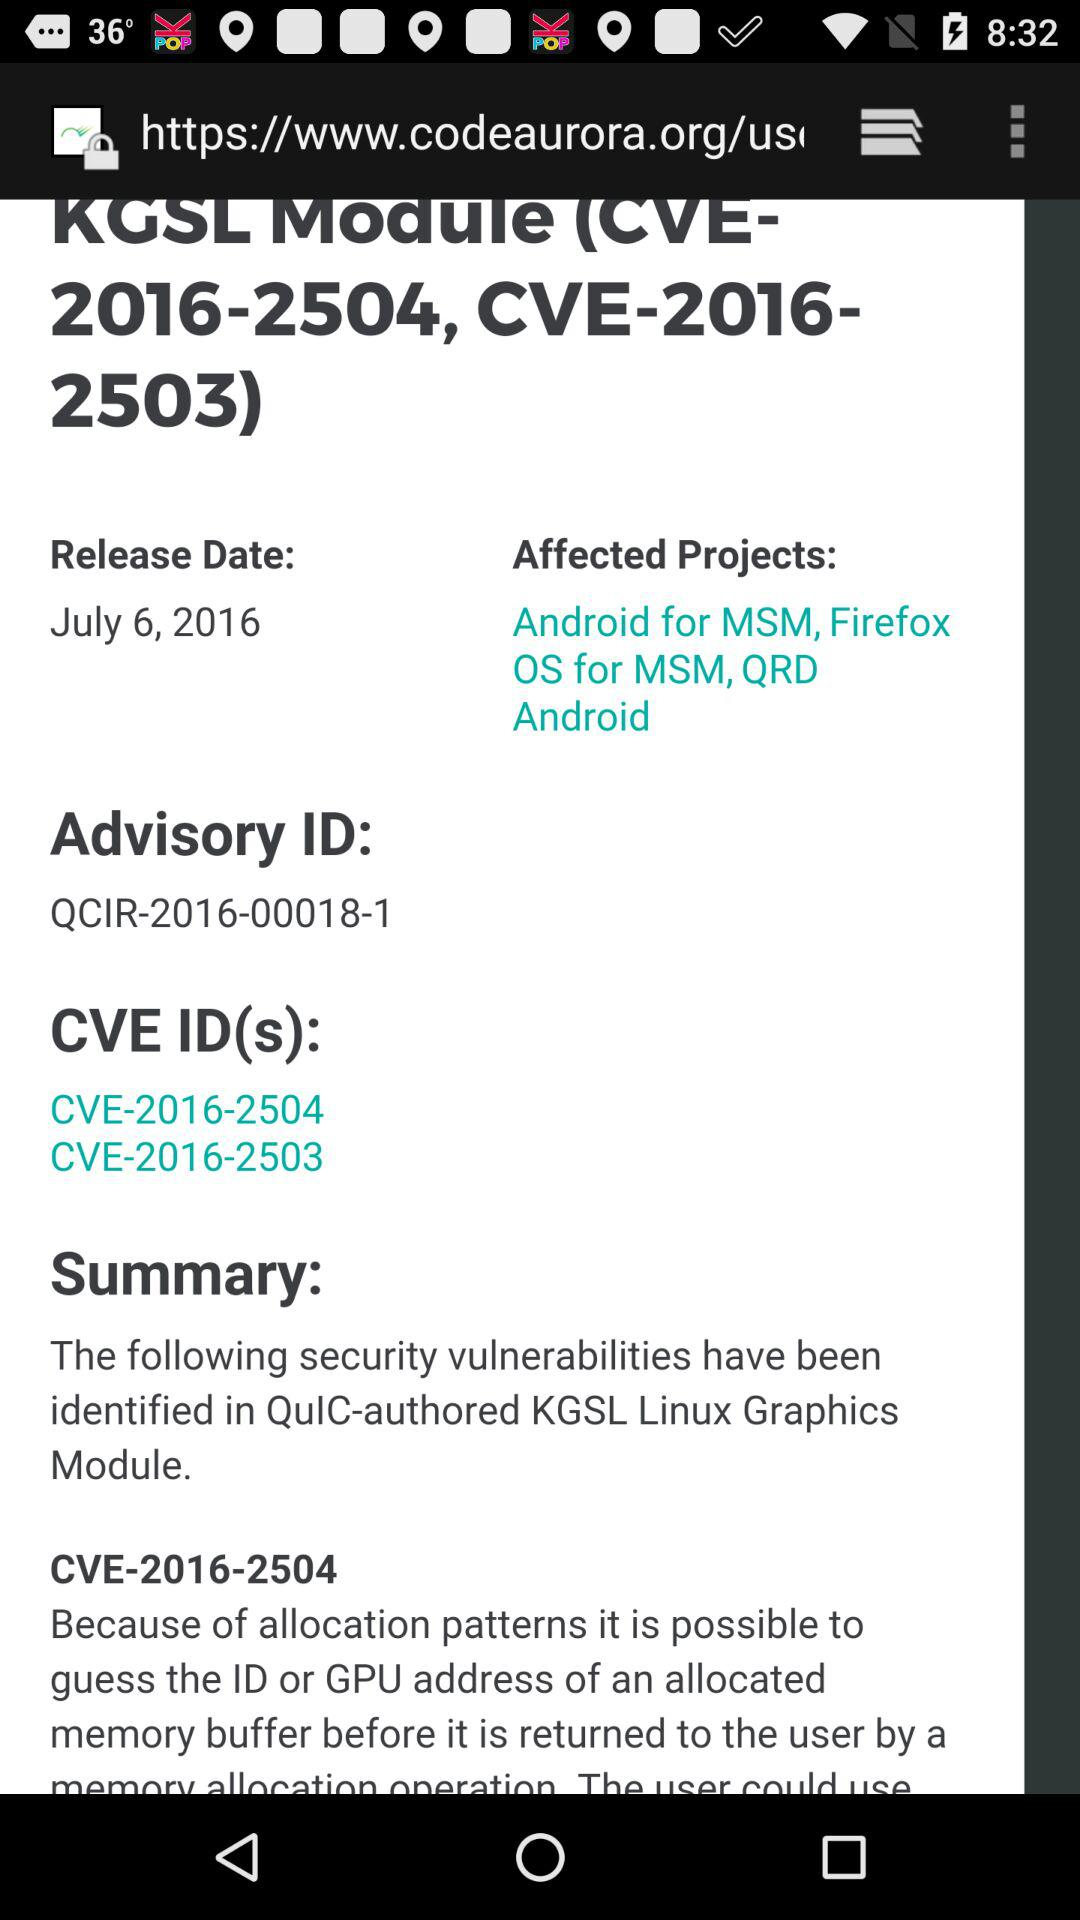What is the release date of the project? The release date of the project is July 6, 2016. 